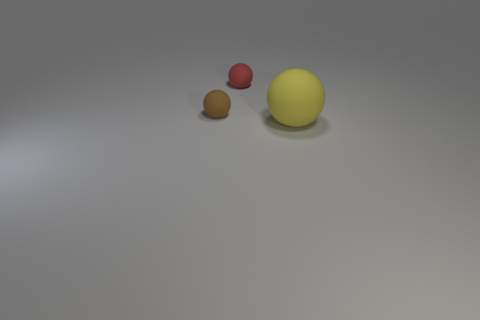Add 1 small matte things. How many objects exist? 4 Subtract all yellow balls. How many balls are left? 2 Subtract all small rubber balls. How many balls are left? 1 Subtract 3 balls. How many balls are left? 0 Subtract all brown blocks. How many brown balls are left? 1 Add 3 tiny brown rubber spheres. How many tiny brown rubber spheres are left? 4 Add 2 big green spheres. How many big green spheres exist? 2 Subtract 0 gray balls. How many objects are left? 3 Subtract all yellow balls. Subtract all cyan cylinders. How many balls are left? 2 Subtract all small brown rubber things. Subtract all big brown blocks. How many objects are left? 2 